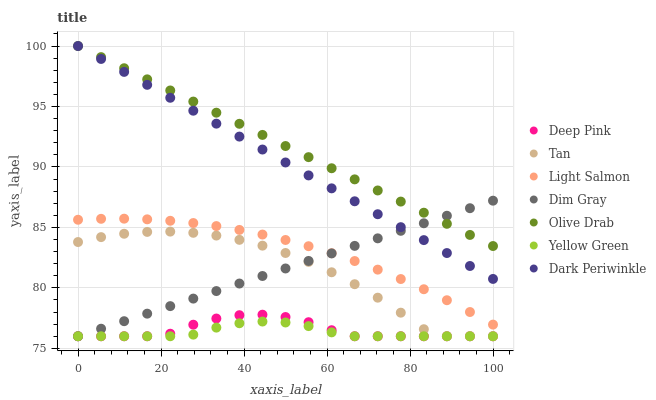Does Yellow Green have the minimum area under the curve?
Answer yes or no. Yes. Does Olive Drab have the maximum area under the curve?
Answer yes or no. Yes. Does Deep Pink have the minimum area under the curve?
Answer yes or no. No. Does Deep Pink have the maximum area under the curve?
Answer yes or no. No. Is Dark Periwinkle the smoothest?
Answer yes or no. Yes. Is Tan the roughest?
Answer yes or no. Yes. Is Deep Pink the smoothest?
Answer yes or no. No. Is Deep Pink the roughest?
Answer yes or no. No. Does Deep Pink have the lowest value?
Answer yes or no. Yes. Does Dark Periwinkle have the lowest value?
Answer yes or no. No. Does Olive Drab have the highest value?
Answer yes or no. Yes. Does Deep Pink have the highest value?
Answer yes or no. No. Is Yellow Green less than Olive Drab?
Answer yes or no. Yes. Is Dark Periwinkle greater than Tan?
Answer yes or no. Yes. Does Dim Gray intersect Deep Pink?
Answer yes or no. Yes. Is Dim Gray less than Deep Pink?
Answer yes or no. No. Is Dim Gray greater than Deep Pink?
Answer yes or no. No. Does Yellow Green intersect Olive Drab?
Answer yes or no. No. 